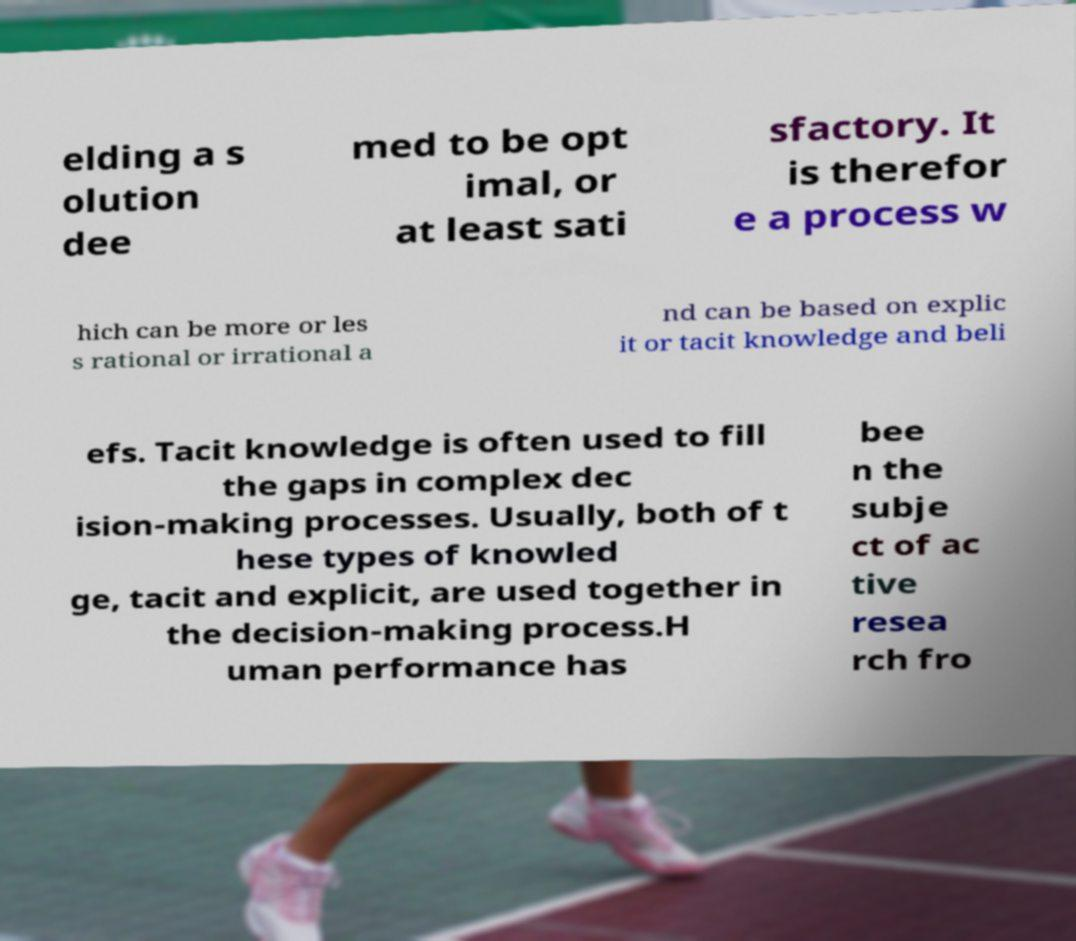What messages or text are displayed in this image? I need them in a readable, typed format. elding a s olution dee med to be opt imal, or at least sati sfactory. It is therefor e a process w hich can be more or les s rational or irrational a nd can be based on explic it or tacit knowledge and beli efs. Tacit knowledge is often used to fill the gaps in complex dec ision-making processes. Usually, both of t hese types of knowled ge, tacit and explicit, are used together in the decision-making process.H uman performance has bee n the subje ct of ac tive resea rch fro 